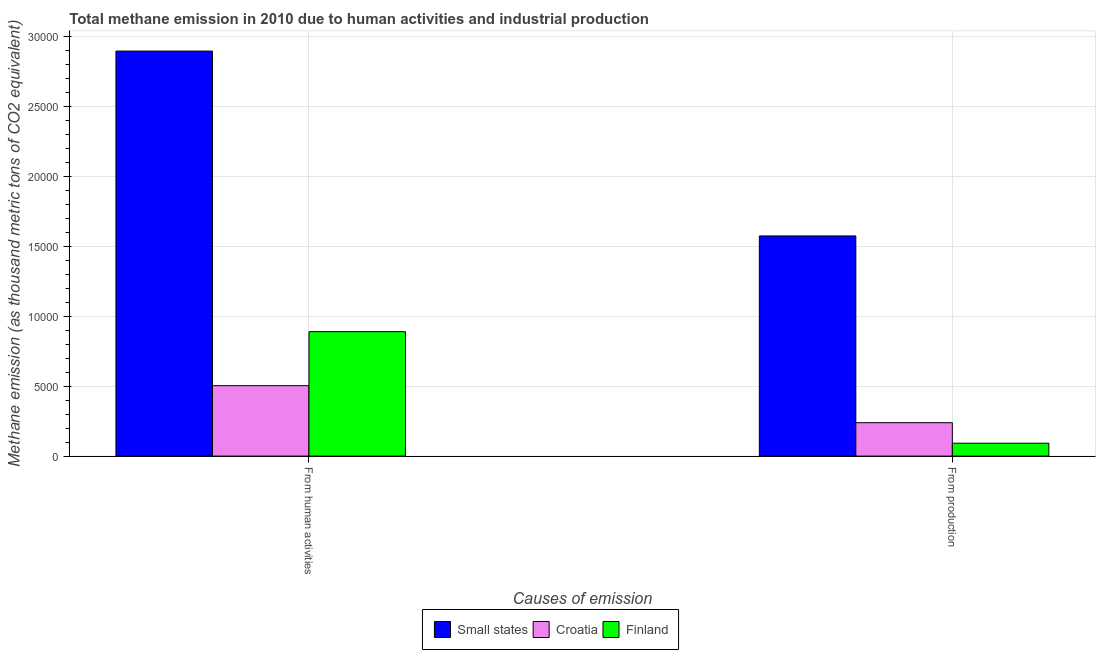How many different coloured bars are there?
Your response must be concise. 3. How many bars are there on the 2nd tick from the right?
Offer a terse response. 3. What is the label of the 2nd group of bars from the left?
Ensure brevity in your answer.  From production. What is the amount of emissions from human activities in Small states?
Keep it short and to the point. 2.90e+04. Across all countries, what is the maximum amount of emissions from human activities?
Offer a terse response. 2.90e+04. Across all countries, what is the minimum amount of emissions from human activities?
Your answer should be compact. 5036. In which country was the amount of emissions from human activities maximum?
Offer a terse response. Small states. In which country was the amount of emissions from human activities minimum?
Give a very brief answer. Croatia. What is the total amount of emissions from human activities in the graph?
Keep it short and to the point. 4.29e+04. What is the difference between the amount of emissions from human activities in Croatia and that in Finland?
Your answer should be compact. -3859.5. What is the difference between the amount of emissions generated from industries in Finland and the amount of emissions from human activities in Croatia?
Your response must be concise. -4114.1. What is the average amount of emissions generated from industries per country?
Provide a succinct answer. 6350.5. What is the difference between the amount of emissions from human activities and amount of emissions generated from industries in Finland?
Provide a short and direct response. 7973.6. In how many countries, is the amount of emissions from human activities greater than 17000 thousand metric tons?
Your response must be concise. 1. What is the ratio of the amount of emissions from human activities in Small states to that in Finland?
Give a very brief answer. 3.26. What does the 3rd bar from the left in From human activities represents?
Give a very brief answer. Finland. What does the 1st bar from the right in From production represents?
Your response must be concise. Finland. Are all the bars in the graph horizontal?
Provide a succinct answer. No. What is the difference between two consecutive major ticks on the Y-axis?
Your answer should be very brief. 5000. Does the graph contain any zero values?
Offer a terse response. No. Does the graph contain grids?
Ensure brevity in your answer.  Yes. What is the title of the graph?
Provide a succinct answer. Total methane emission in 2010 due to human activities and industrial production. Does "United Kingdom" appear as one of the legend labels in the graph?
Your response must be concise. No. What is the label or title of the X-axis?
Keep it short and to the point. Causes of emission. What is the label or title of the Y-axis?
Provide a short and direct response. Methane emission (as thousand metric tons of CO2 equivalent). What is the Methane emission (as thousand metric tons of CO2 equivalent) of Small states in From human activities?
Your response must be concise. 2.90e+04. What is the Methane emission (as thousand metric tons of CO2 equivalent) in Croatia in From human activities?
Your answer should be compact. 5036. What is the Methane emission (as thousand metric tons of CO2 equivalent) in Finland in From human activities?
Keep it short and to the point. 8895.5. What is the Methane emission (as thousand metric tons of CO2 equivalent) of Small states in From production?
Provide a short and direct response. 1.57e+04. What is the Methane emission (as thousand metric tons of CO2 equivalent) in Croatia in From production?
Ensure brevity in your answer.  2389.3. What is the Methane emission (as thousand metric tons of CO2 equivalent) in Finland in From production?
Keep it short and to the point. 921.9. Across all Causes of emission, what is the maximum Methane emission (as thousand metric tons of CO2 equivalent) of Small states?
Ensure brevity in your answer.  2.90e+04. Across all Causes of emission, what is the maximum Methane emission (as thousand metric tons of CO2 equivalent) in Croatia?
Offer a very short reply. 5036. Across all Causes of emission, what is the maximum Methane emission (as thousand metric tons of CO2 equivalent) in Finland?
Offer a terse response. 8895.5. Across all Causes of emission, what is the minimum Methane emission (as thousand metric tons of CO2 equivalent) of Small states?
Provide a short and direct response. 1.57e+04. Across all Causes of emission, what is the minimum Methane emission (as thousand metric tons of CO2 equivalent) in Croatia?
Give a very brief answer. 2389.3. Across all Causes of emission, what is the minimum Methane emission (as thousand metric tons of CO2 equivalent) in Finland?
Your answer should be very brief. 921.9. What is the total Methane emission (as thousand metric tons of CO2 equivalent) of Small states in the graph?
Provide a short and direct response. 4.47e+04. What is the total Methane emission (as thousand metric tons of CO2 equivalent) of Croatia in the graph?
Make the answer very short. 7425.3. What is the total Methane emission (as thousand metric tons of CO2 equivalent) in Finland in the graph?
Provide a succinct answer. 9817.4. What is the difference between the Methane emission (as thousand metric tons of CO2 equivalent) in Small states in From human activities and that in From production?
Your response must be concise. 1.32e+04. What is the difference between the Methane emission (as thousand metric tons of CO2 equivalent) in Croatia in From human activities and that in From production?
Offer a very short reply. 2646.7. What is the difference between the Methane emission (as thousand metric tons of CO2 equivalent) in Finland in From human activities and that in From production?
Make the answer very short. 7973.6. What is the difference between the Methane emission (as thousand metric tons of CO2 equivalent) of Small states in From human activities and the Methane emission (as thousand metric tons of CO2 equivalent) of Croatia in From production?
Provide a succinct answer. 2.66e+04. What is the difference between the Methane emission (as thousand metric tons of CO2 equivalent) of Small states in From human activities and the Methane emission (as thousand metric tons of CO2 equivalent) of Finland in From production?
Your response must be concise. 2.80e+04. What is the difference between the Methane emission (as thousand metric tons of CO2 equivalent) in Croatia in From human activities and the Methane emission (as thousand metric tons of CO2 equivalent) in Finland in From production?
Give a very brief answer. 4114.1. What is the average Methane emission (as thousand metric tons of CO2 equivalent) in Small states per Causes of emission?
Your answer should be compact. 2.23e+04. What is the average Methane emission (as thousand metric tons of CO2 equivalent) in Croatia per Causes of emission?
Keep it short and to the point. 3712.65. What is the average Methane emission (as thousand metric tons of CO2 equivalent) in Finland per Causes of emission?
Give a very brief answer. 4908.7. What is the difference between the Methane emission (as thousand metric tons of CO2 equivalent) in Small states and Methane emission (as thousand metric tons of CO2 equivalent) in Croatia in From human activities?
Your response must be concise. 2.39e+04. What is the difference between the Methane emission (as thousand metric tons of CO2 equivalent) in Small states and Methane emission (as thousand metric tons of CO2 equivalent) in Finland in From human activities?
Your answer should be very brief. 2.01e+04. What is the difference between the Methane emission (as thousand metric tons of CO2 equivalent) in Croatia and Methane emission (as thousand metric tons of CO2 equivalent) in Finland in From human activities?
Give a very brief answer. -3859.5. What is the difference between the Methane emission (as thousand metric tons of CO2 equivalent) of Small states and Methane emission (as thousand metric tons of CO2 equivalent) of Croatia in From production?
Give a very brief answer. 1.34e+04. What is the difference between the Methane emission (as thousand metric tons of CO2 equivalent) in Small states and Methane emission (as thousand metric tons of CO2 equivalent) in Finland in From production?
Your answer should be very brief. 1.48e+04. What is the difference between the Methane emission (as thousand metric tons of CO2 equivalent) in Croatia and Methane emission (as thousand metric tons of CO2 equivalent) in Finland in From production?
Your response must be concise. 1467.4. What is the ratio of the Methane emission (as thousand metric tons of CO2 equivalent) in Small states in From human activities to that in From production?
Keep it short and to the point. 1.84. What is the ratio of the Methane emission (as thousand metric tons of CO2 equivalent) of Croatia in From human activities to that in From production?
Provide a short and direct response. 2.11. What is the ratio of the Methane emission (as thousand metric tons of CO2 equivalent) of Finland in From human activities to that in From production?
Give a very brief answer. 9.65. What is the difference between the highest and the second highest Methane emission (as thousand metric tons of CO2 equivalent) in Small states?
Give a very brief answer. 1.32e+04. What is the difference between the highest and the second highest Methane emission (as thousand metric tons of CO2 equivalent) in Croatia?
Offer a terse response. 2646.7. What is the difference between the highest and the second highest Methane emission (as thousand metric tons of CO2 equivalent) in Finland?
Make the answer very short. 7973.6. What is the difference between the highest and the lowest Methane emission (as thousand metric tons of CO2 equivalent) in Small states?
Give a very brief answer. 1.32e+04. What is the difference between the highest and the lowest Methane emission (as thousand metric tons of CO2 equivalent) of Croatia?
Keep it short and to the point. 2646.7. What is the difference between the highest and the lowest Methane emission (as thousand metric tons of CO2 equivalent) in Finland?
Give a very brief answer. 7973.6. 